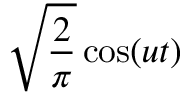Convert formula to latex. <formula><loc_0><loc_0><loc_500><loc_500>{ \sqrt { \frac { 2 } { \pi } } } \cos ( u t )</formula> 